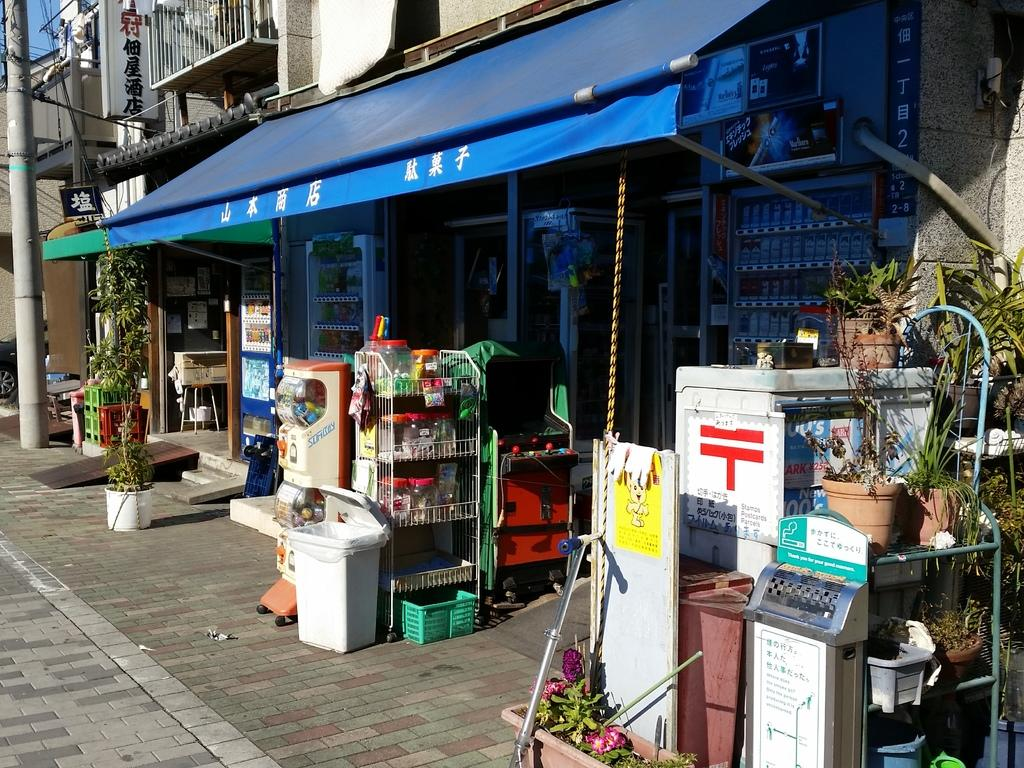<image>
Summarize the visual content of the image. A store with a blue awning with words written in chinese or japanese. 